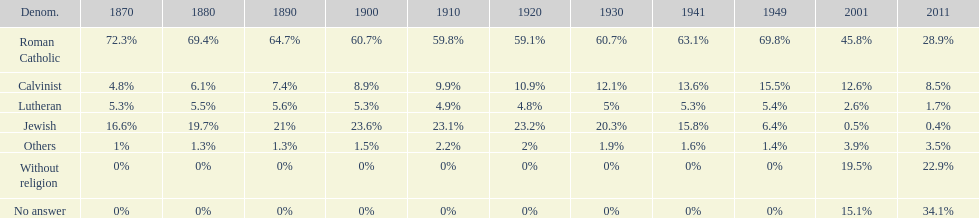The percentage of people who identified as calvinist was, at most, how much? 15.5%. 